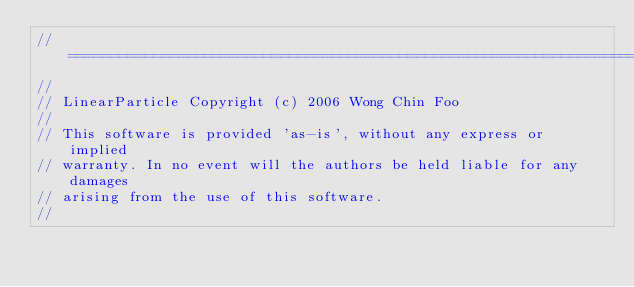Convert code to text. <code><loc_0><loc_0><loc_500><loc_500><_C++_>//===============================================================================
//
// LinearParticle Copyright (c) 2006 Wong Chin Foo
//
// This software is provided 'as-is', without any express or implied
// warranty. In no event will the authors be held liable for any damages
// arising from the use of this software.
//</code> 